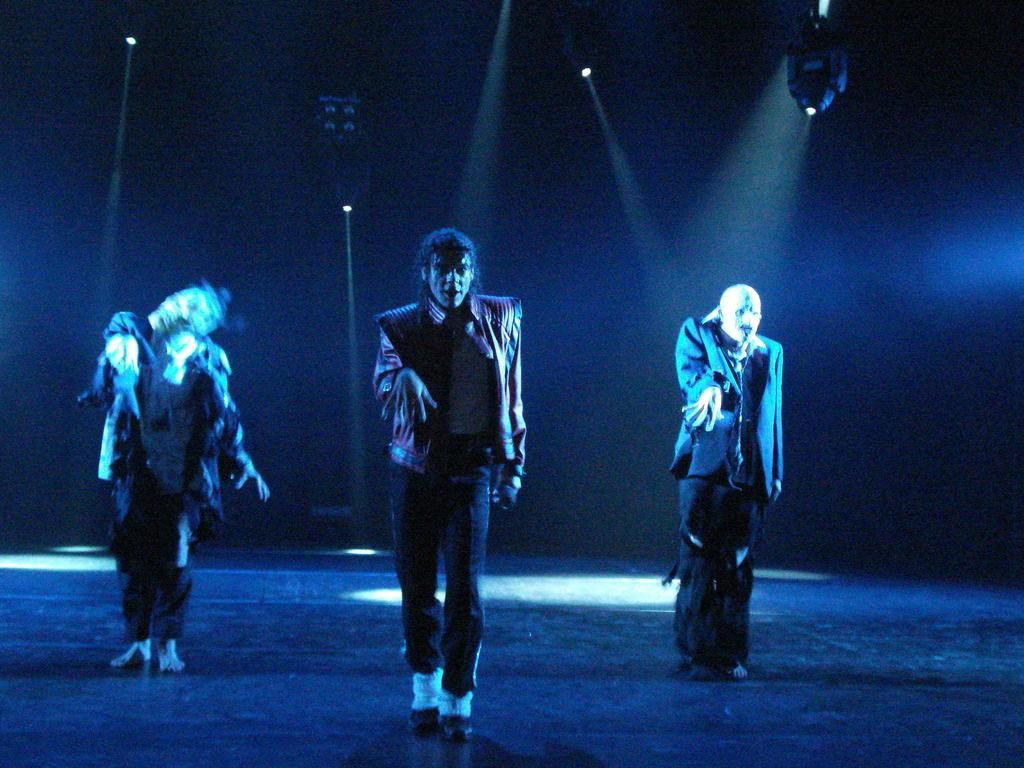What are the people in the image doing? The people in the image are standing on the ground. How would you describe the background of the image? The background of the image is dark. What can be seen in addition to the people in the image? There are lights visible in the image. Can you describe the object at the top of the image? Unfortunately, the facts provided do not give enough information to describe the object at the top of the image. How many kittens are playing with the cannon in the image? There are no kittens or cannons present in the image. What type of mist can be seen surrounding the people in the image? There is no mention of mist in the provided facts, and therefore it cannot be determined if mist is present in the image. 